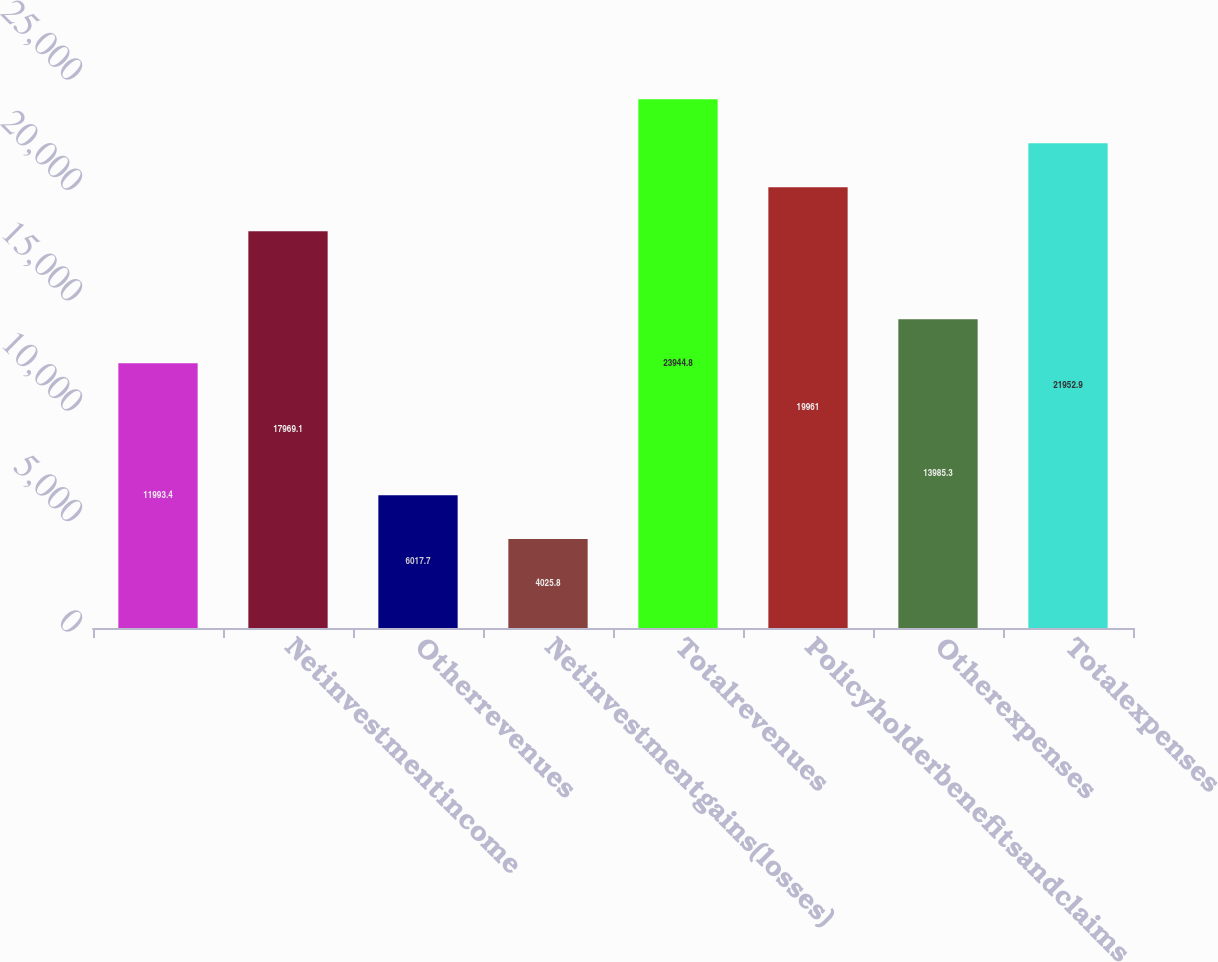Convert chart to OTSL. <chart><loc_0><loc_0><loc_500><loc_500><bar_chart><ecel><fcel>Netinvestmentincome<fcel>Otherrevenues<fcel>Netinvestmentgains(losses)<fcel>Totalrevenues<fcel>Policyholderbenefitsandclaims<fcel>Otherexpenses<fcel>Totalexpenses<nl><fcel>11993.4<fcel>17969.1<fcel>6017.7<fcel>4025.8<fcel>23944.8<fcel>19961<fcel>13985.3<fcel>21952.9<nl></chart> 